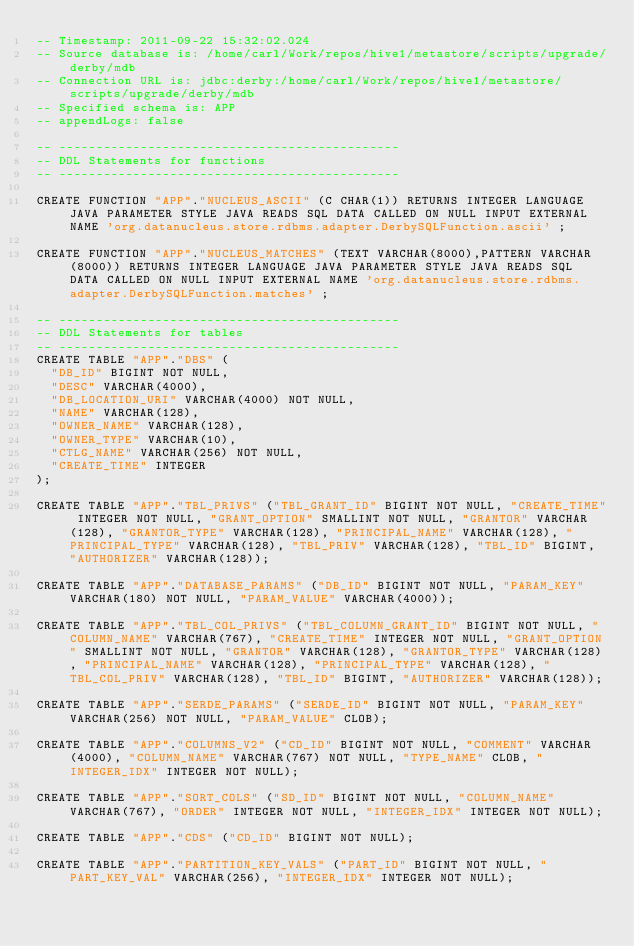Convert code to text. <code><loc_0><loc_0><loc_500><loc_500><_SQL_>-- Timestamp: 2011-09-22 15:32:02.024
-- Source database is: /home/carl/Work/repos/hive1/metastore/scripts/upgrade/derby/mdb
-- Connection URL is: jdbc:derby:/home/carl/Work/repos/hive1/metastore/scripts/upgrade/derby/mdb
-- Specified schema is: APP
-- appendLogs: false

-- ----------------------------------------------
-- DDL Statements for functions
-- ----------------------------------------------

CREATE FUNCTION "APP"."NUCLEUS_ASCII" (C CHAR(1)) RETURNS INTEGER LANGUAGE JAVA PARAMETER STYLE JAVA READS SQL DATA CALLED ON NULL INPUT EXTERNAL NAME 'org.datanucleus.store.rdbms.adapter.DerbySQLFunction.ascii' ;

CREATE FUNCTION "APP"."NUCLEUS_MATCHES" (TEXT VARCHAR(8000),PATTERN VARCHAR(8000)) RETURNS INTEGER LANGUAGE JAVA PARAMETER STYLE JAVA READS SQL DATA CALLED ON NULL INPUT EXTERNAL NAME 'org.datanucleus.store.rdbms.adapter.DerbySQLFunction.matches' ;

-- ----------------------------------------------
-- DDL Statements for tables
-- ----------------------------------------------
CREATE TABLE "APP"."DBS" (
  "DB_ID" BIGINT NOT NULL,
  "DESC" VARCHAR(4000),
  "DB_LOCATION_URI" VARCHAR(4000) NOT NULL,
  "NAME" VARCHAR(128),
  "OWNER_NAME" VARCHAR(128),
  "OWNER_TYPE" VARCHAR(10),
  "CTLG_NAME" VARCHAR(256) NOT NULL,
  "CREATE_TIME" INTEGER
);

CREATE TABLE "APP"."TBL_PRIVS" ("TBL_GRANT_ID" BIGINT NOT NULL, "CREATE_TIME" INTEGER NOT NULL, "GRANT_OPTION" SMALLINT NOT NULL, "GRANTOR" VARCHAR(128), "GRANTOR_TYPE" VARCHAR(128), "PRINCIPAL_NAME" VARCHAR(128), "PRINCIPAL_TYPE" VARCHAR(128), "TBL_PRIV" VARCHAR(128), "TBL_ID" BIGINT, "AUTHORIZER" VARCHAR(128));

CREATE TABLE "APP"."DATABASE_PARAMS" ("DB_ID" BIGINT NOT NULL, "PARAM_KEY" VARCHAR(180) NOT NULL, "PARAM_VALUE" VARCHAR(4000));

CREATE TABLE "APP"."TBL_COL_PRIVS" ("TBL_COLUMN_GRANT_ID" BIGINT NOT NULL, "COLUMN_NAME" VARCHAR(767), "CREATE_TIME" INTEGER NOT NULL, "GRANT_OPTION" SMALLINT NOT NULL, "GRANTOR" VARCHAR(128), "GRANTOR_TYPE" VARCHAR(128), "PRINCIPAL_NAME" VARCHAR(128), "PRINCIPAL_TYPE" VARCHAR(128), "TBL_COL_PRIV" VARCHAR(128), "TBL_ID" BIGINT, "AUTHORIZER" VARCHAR(128));

CREATE TABLE "APP"."SERDE_PARAMS" ("SERDE_ID" BIGINT NOT NULL, "PARAM_KEY" VARCHAR(256) NOT NULL, "PARAM_VALUE" CLOB);

CREATE TABLE "APP"."COLUMNS_V2" ("CD_ID" BIGINT NOT NULL, "COMMENT" VARCHAR(4000), "COLUMN_NAME" VARCHAR(767) NOT NULL, "TYPE_NAME" CLOB, "INTEGER_IDX" INTEGER NOT NULL);

CREATE TABLE "APP"."SORT_COLS" ("SD_ID" BIGINT NOT NULL, "COLUMN_NAME" VARCHAR(767), "ORDER" INTEGER NOT NULL, "INTEGER_IDX" INTEGER NOT NULL);

CREATE TABLE "APP"."CDS" ("CD_ID" BIGINT NOT NULL);

CREATE TABLE "APP"."PARTITION_KEY_VALS" ("PART_ID" BIGINT NOT NULL, "PART_KEY_VAL" VARCHAR(256), "INTEGER_IDX" INTEGER NOT NULL);
</code> 